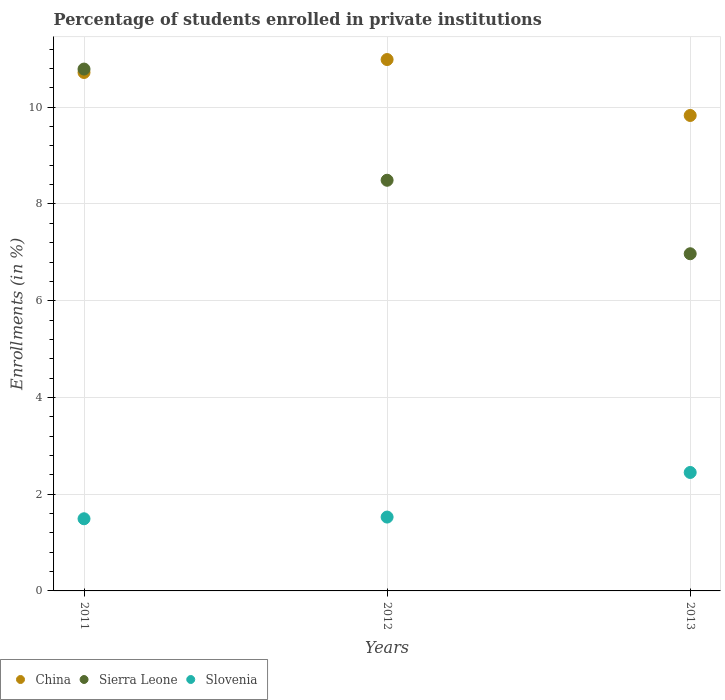How many different coloured dotlines are there?
Provide a succinct answer. 3. What is the percentage of trained teachers in China in 2012?
Offer a very short reply. 10.99. Across all years, what is the maximum percentage of trained teachers in Slovenia?
Your response must be concise. 2.45. Across all years, what is the minimum percentage of trained teachers in China?
Provide a succinct answer. 9.83. In which year was the percentage of trained teachers in Slovenia minimum?
Your answer should be compact. 2011. What is the total percentage of trained teachers in Sierra Leone in the graph?
Your response must be concise. 26.25. What is the difference between the percentage of trained teachers in Slovenia in 2012 and that in 2013?
Offer a terse response. -0.92. What is the difference between the percentage of trained teachers in Sierra Leone in 2011 and the percentage of trained teachers in Slovenia in 2013?
Offer a very short reply. 8.34. What is the average percentage of trained teachers in Slovenia per year?
Offer a very short reply. 1.82. In the year 2012, what is the difference between the percentage of trained teachers in Slovenia and percentage of trained teachers in Sierra Leone?
Offer a terse response. -6.96. What is the ratio of the percentage of trained teachers in Sierra Leone in 2011 to that in 2013?
Make the answer very short. 1.55. Is the difference between the percentage of trained teachers in Slovenia in 2012 and 2013 greater than the difference between the percentage of trained teachers in Sierra Leone in 2012 and 2013?
Offer a very short reply. No. What is the difference between the highest and the second highest percentage of trained teachers in Slovenia?
Your answer should be compact. 0.92. What is the difference between the highest and the lowest percentage of trained teachers in Slovenia?
Provide a short and direct response. 0.96. Is the percentage of trained teachers in Sierra Leone strictly greater than the percentage of trained teachers in China over the years?
Your answer should be compact. No. How many dotlines are there?
Provide a short and direct response. 3. Does the graph contain any zero values?
Ensure brevity in your answer.  No. Where does the legend appear in the graph?
Give a very brief answer. Bottom left. How many legend labels are there?
Your answer should be compact. 3. How are the legend labels stacked?
Give a very brief answer. Horizontal. What is the title of the graph?
Give a very brief answer. Percentage of students enrolled in private institutions. What is the label or title of the Y-axis?
Your answer should be very brief. Enrollments (in %). What is the Enrollments (in %) of China in 2011?
Offer a very short reply. 10.72. What is the Enrollments (in %) of Sierra Leone in 2011?
Offer a very short reply. 10.79. What is the Enrollments (in %) in Slovenia in 2011?
Provide a short and direct response. 1.49. What is the Enrollments (in %) in China in 2012?
Your answer should be compact. 10.99. What is the Enrollments (in %) in Sierra Leone in 2012?
Keep it short and to the point. 8.49. What is the Enrollments (in %) in Slovenia in 2012?
Keep it short and to the point. 1.53. What is the Enrollments (in %) of China in 2013?
Your answer should be very brief. 9.83. What is the Enrollments (in %) of Sierra Leone in 2013?
Ensure brevity in your answer.  6.97. What is the Enrollments (in %) of Slovenia in 2013?
Your answer should be very brief. 2.45. Across all years, what is the maximum Enrollments (in %) of China?
Your answer should be compact. 10.99. Across all years, what is the maximum Enrollments (in %) of Sierra Leone?
Ensure brevity in your answer.  10.79. Across all years, what is the maximum Enrollments (in %) in Slovenia?
Provide a succinct answer. 2.45. Across all years, what is the minimum Enrollments (in %) of China?
Give a very brief answer. 9.83. Across all years, what is the minimum Enrollments (in %) of Sierra Leone?
Provide a succinct answer. 6.97. Across all years, what is the minimum Enrollments (in %) in Slovenia?
Your answer should be very brief. 1.49. What is the total Enrollments (in %) of China in the graph?
Offer a terse response. 31.54. What is the total Enrollments (in %) in Sierra Leone in the graph?
Make the answer very short. 26.25. What is the total Enrollments (in %) of Slovenia in the graph?
Your answer should be compact. 5.47. What is the difference between the Enrollments (in %) of China in 2011 and that in 2012?
Ensure brevity in your answer.  -0.27. What is the difference between the Enrollments (in %) of Sierra Leone in 2011 and that in 2012?
Your response must be concise. 2.3. What is the difference between the Enrollments (in %) in Slovenia in 2011 and that in 2012?
Give a very brief answer. -0.04. What is the difference between the Enrollments (in %) in Sierra Leone in 2011 and that in 2013?
Offer a terse response. 3.82. What is the difference between the Enrollments (in %) of Slovenia in 2011 and that in 2013?
Give a very brief answer. -0.96. What is the difference between the Enrollments (in %) in China in 2012 and that in 2013?
Your answer should be very brief. 1.16. What is the difference between the Enrollments (in %) in Sierra Leone in 2012 and that in 2013?
Provide a succinct answer. 1.52. What is the difference between the Enrollments (in %) of Slovenia in 2012 and that in 2013?
Your answer should be very brief. -0.92. What is the difference between the Enrollments (in %) in China in 2011 and the Enrollments (in %) in Sierra Leone in 2012?
Give a very brief answer. 2.23. What is the difference between the Enrollments (in %) of China in 2011 and the Enrollments (in %) of Slovenia in 2012?
Make the answer very short. 9.19. What is the difference between the Enrollments (in %) of Sierra Leone in 2011 and the Enrollments (in %) of Slovenia in 2012?
Provide a succinct answer. 9.26. What is the difference between the Enrollments (in %) of China in 2011 and the Enrollments (in %) of Sierra Leone in 2013?
Make the answer very short. 3.75. What is the difference between the Enrollments (in %) of China in 2011 and the Enrollments (in %) of Slovenia in 2013?
Give a very brief answer. 8.27. What is the difference between the Enrollments (in %) of Sierra Leone in 2011 and the Enrollments (in %) of Slovenia in 2013?
Your response must be concise. 8.34. What is the difference between the Enrollments (in %) of China in 2012 and the Enrollments (in %) of Sierra Leone in 2013?
Provide a short and direct response. 4.02. What is the difference between the Enrollments (in %) in China in 2012 and the Enrollments (in %) in Slovenia in 2013?
Your answer should be compact. 8.54. What is the difference between the Enrollments (in %) of Sierra Leone in 2012 and the Enrollments (in %) of Slovenia in 2013?
Keep it short and to the point. 6.04. What is the average Enrollments (in %) of China per year?
Your answer should be very brief. 10.51. What is the average Enrollments (in %) in Sierra Leone per year?
Provide a succinct answer. 8.75. What is the average Enrollments (in %) of Slovenia per year?
Offer a very short reply. 1.82. In the year 2011, what is the difference between the Enrollments (in %) of China and Enrollments (in %) of Sierra Leone?
Offer a very short reply. -0.07. In the year 2011, what is the difference between the Enrollments (in %) in China and Enrollments (in %) in Slovenia?
Give a very brief answer. 9.23. In the year 2011, what is the difference between the Enrollments (in %) of Sierra Leone and Enrollments (in %) of Slovenia?
Your answer should be very brief. 9.3. In the year 2012, what is the difference between the Enrollments (in %) of China and Enrollments (in %) of Sierra Leone?
Your answer should be very brief. 2.5. In the year 2012, what is the difference between the Enrollments (in %) in China and Enrollments (in %) in Slovenia?
Offer a very short reply. 9.46. In the year 2012, what is the difference between the Enrollments (in %) in Sierra Leone and Enrollments (in %) in Slovenia?
Give a very brief answer. 6.96. In the year 2013, what is the difference between the Enrollments (in %) in China and Enrollments (in %) in Sierra Leone?
Your response must be concise. 2.86. In the year 2013, what is the difference between the Enrollments (in %) of China and Enrollments (in %) of Slovenia?
Provide a short and direct response. 7.38. In the year 2013, what is the difference between the Enrollments (in %) of Sierra Leone and Enrollments (in %) of Slovenia?
Provide a short and direct response. 4.52. What is the ratio of the Enrollments (in %) in China in 2011 to that in 2012?
Offer a very short reply. 0.98. What is the ratio of the Enrollments (in %) of Sierra Leone in 2011 to that in 2012?
Offer a very short reply. 1.27. What is the ratio of the Enrollments (in %) of China in 2011 to that in 2013?
Offer a very short reply. 1.09. What is the ratio of the Enrollments (in %) in Sierra Leone in 2011 to that in 2013?
Offer a very short reply. 1.55. What is the ratio of the Enrollments (in %) of Slovenia in 2011 to that in 2013?
Your response must be concise. 0.61. What is the ratio of the Enrollments (in %) in China in 2012 to that in 2013?
Your answer should be compact. 1.12. What is the ratio of the Enrollments (in %) of Sierra Leone in 2012 to that in 2013?
Your response must be concise. 1.22. What is the ratio of the Enrollments (in %) in Slovenia in 2012 to that in 2013?
Offer a terse response. 0.62. What is the difference between the highest and the second highest Enrollments (in %) of China?
Provide a succinct answer. 0.27. What is the difference between the highest and the second highest Enrollments (in %) in Sierra Leone?
Your response must be concise. 2.3. What is the difference between the highest and the second highest Enrollments (in %) of Slovenia?
Ensure brevity in your answer.  0.92. What is the difference between the highest and the lowest Enrollments (in %) of China?
Ensure brevity in your answer.  1.16. What is the difference between the highest and the lowest Enrollments (in %) of Sierra Leone?
Ensure brevity in your answer.  3.82. What is the difference between the highest and the lowest Enrollments (in %) of Slovenia?
Your response must be concise. 0.96. 